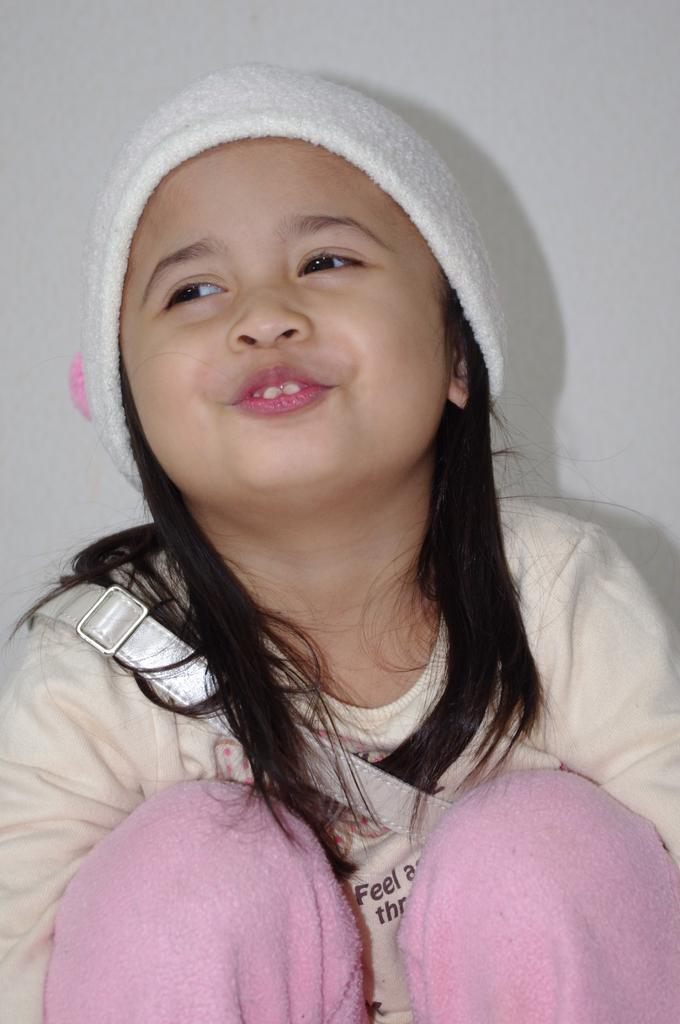Who is the main subject in the image? There is a girl in the image. What is the girl wearing on her head? The girl is wearing a white cap. What else is the girl carrying in the image? The girl is wearing a bag. What can be seen behind the girl in the image? There is a plain wall in the background of the image. What type of fowl is standing next to the girl in the image? There is no fowl present in the image; it only features the girl wearing a white cap and a bag. 